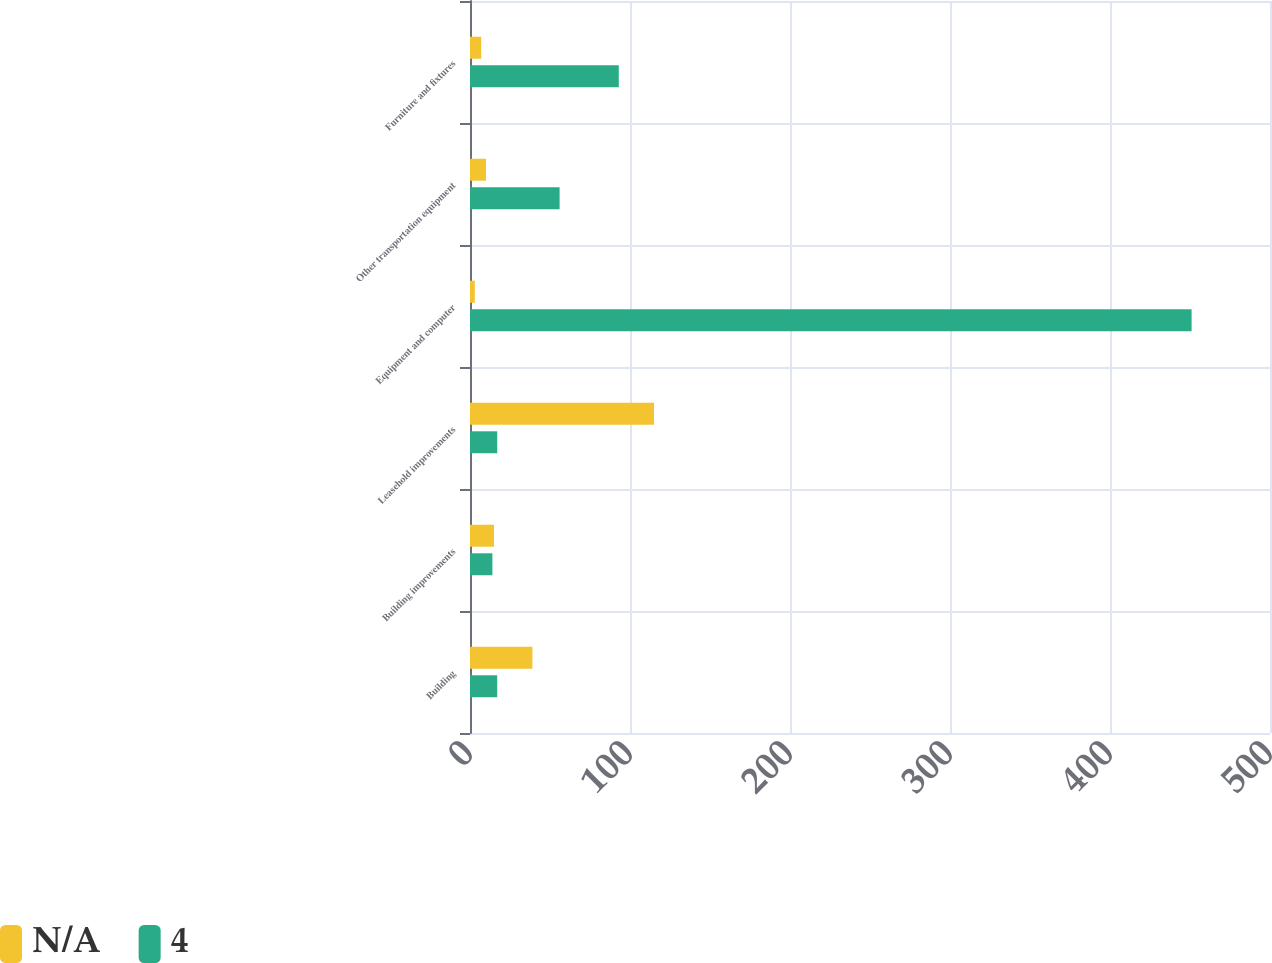<chart> <loc_0><loc_0><loc_500><loc_500><stacked_bar_chart><ecel><fcel>Building<fcel>Building improvements<fcel>Leasehold improvements<fcel>Equipment and computer<fcel>Other transportation equipment<fcel>Furniture and fixtures<nl><fcel>nan<fcel>39<fcel>15<fcel>115<fcel>3<fcel>10<fcel>7<nl><fcel>4<fcel>17<fcel>14<fcel>17<fcel>451<fcel>56<fcel>93<nl></chart> 